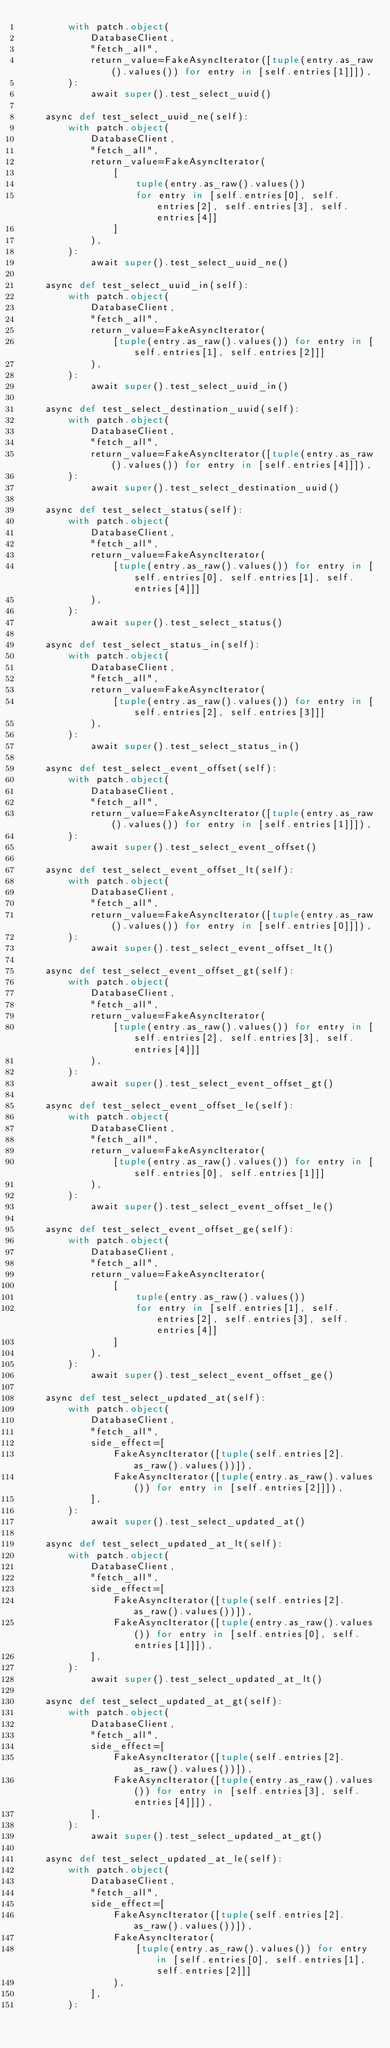<code> <loc_0><loc_0><loc_500><loc_500><_Python_>        with patch.object(
            DatabaseClient,
            "fetch_all",
            return_value=FakeAsyncIterator([tuple(entry.as_raw().values()) for entry in [self.entries[1]]]),
        ):
            await super().test_select_uuid()

    async def test_select_uuid_ne(self):
        with patch.object(
            DatabaseClient,
            "fetch_all",
            return_value=FakeAsyncIterator(
                [
                    tuple(entry.as_raw().values())
                    for entry in [self.entries[0], self.entries[2], self.entries[3], self.entries[4]]
                ]
            ),
        ):
            await super().test_select_uuid_ne()

    async def test_select_uuid_in(self):
        with patch.object(
            DatabaseClient,
            "fetch_all",
            return_value=FakeAsyncIterator(
                [tuple(entry.as_raw().values()) for entry in [self.entries[1], self.entries[2]]]
            ),
        ):
            await super().test_select_uuid_in()

    async def test_select_destination_uuid(self):
        with patch.object(
            DatabaseClient,
            "fetch_all",
            return_value=FakeAsyncIterator([tuple(entry.as_raw().values()) for entry in [self.entries[4]]]),
        ):
            await super().test_select_destination_uuid()

    async def test_select_status(self):
        with patch.object(
            DatabaseClient,
            "fetch_all",
            return_value=FakeAsyncIterator(
                [tuple(entry.as_raw().values()) for entry in [self.entries[0], self.entries[1], self.entries[4]]]
            ),
        ):
            await super().test_select_status()

    async def test_select_status_in(self):
        with patch.object(
            DatabaseClient,
            "fetch_all",
            return_value=FakeAsyncIterator(
                [tuple(entry.as_raw().values()) for entry in [self.entries[2], self.entries[3]]]
            ),
        ):
            await super().test_select_status_in()

    async def test_select_event_offset(self):
        with patch.object(
            DatabaseClient,
            "fetch_all",
            return_value=FakeAsyncIterator([tuple(entry.as_raw().values()) for entry in [self.entries[1]]]),
        ):
            await super().test_select_event_offset()

    async def test_select_event_offset_lt(self):
        with patch.object(
            DatabaseClient,
            "fetch_all",
            return_value=FakeAsyncIterator([tuple(entry.as_raw().values()) for entry in [self.entries[0]]]),
        ):
            await super().test_select_event_offset_lt()

    async def test_select_event_offset_gt(self):
        with patch.object(
            DatabaseClient,
            "fetch_all",
            return_value=FakeAsyncIterator(
                [tuple(entry.as_raw().values()) for entry in [self.entries[2], self.entries[3], self.entries[4]]]
            ),
        ):
            await super().test_select_event_offset_gt()

    async def test_select_event_offset_le(self):
        with patch.object(
            DatabaseClient,
            "fetch_all",
            return_value=FakeAsyncIterator(
                [tuple(entry.as_raw().values()) for entry in [self.entries[0], self.entries[1]]]
            ),
        ):
            await super().test_select_event_offset_le()

    async def test_select_event_offset_ge(self):
        with patch.object(
            DatabaseClient,
            "fetch_all",
            return_value=FakeAsyncIterator(
                [
                    tuple(entry.as_raw().values())
                    for entry in [self.entries[1], self.entries[2], self.entries[3], self.entries[4]]
                ]
            ),
        ):
            await super().test_select_event_offset_ge()

    async def test_select_updated_at(self):
        with patch.object(
            DatabaseClient,
            "fetch_all",
            side_effect=[
                FakeAsyncIterator([tuple(self.entries[2].as_raw().values())]),
                FakeAsyncIterator([tuple(entry.as_raw().values()) for entry in [self.entries[2]]]),
            ],
        ):
            await super().test_select_updated_at()

    async def test_select_updated_at_lt(self):
        with patch.object(
            DatabaseClient,
            "fetch_all",
            side_effect=[
                FakeAsyncIterator([tuple(self.entries[2].as_raw().values())]),
                FakeAsyncIterator([tuple(entry.as_raw().values()) for entry in [self.entries[0], self.entries[1]]]),
            ],
        ):
            await super().test_select_updated_at_lt()

    async def test_select_updated_at_gt(self):
        with patch.object(
            DatabaseClient,
            "fetch_all",
            side_effect=[
                FakeAsyncIterator([tuple(self.entries[2].as_raw().values())]),
                FakeAsyncIterator([tuple(entry.as_raw().values()) for entry in [self.entries[3], self.entries[4]]]),
            ],
        ):
            await super().test_select_updated_at_gt()

    async def test_select_updated_at_le(self):
        with patch.object(
            DatabaseClient,
            "fetch_all",
            side_effect=[
                FakeAsyncIterator([tuple(self.entries[2].as_raw().values())]),
                FakeAsyncIterator(
                    [tuple(entry.as_raw().values()) for entry in [self.entries[0], self.entries[1], self.entries[2]]]
                ),
            ],
        ):</code> 